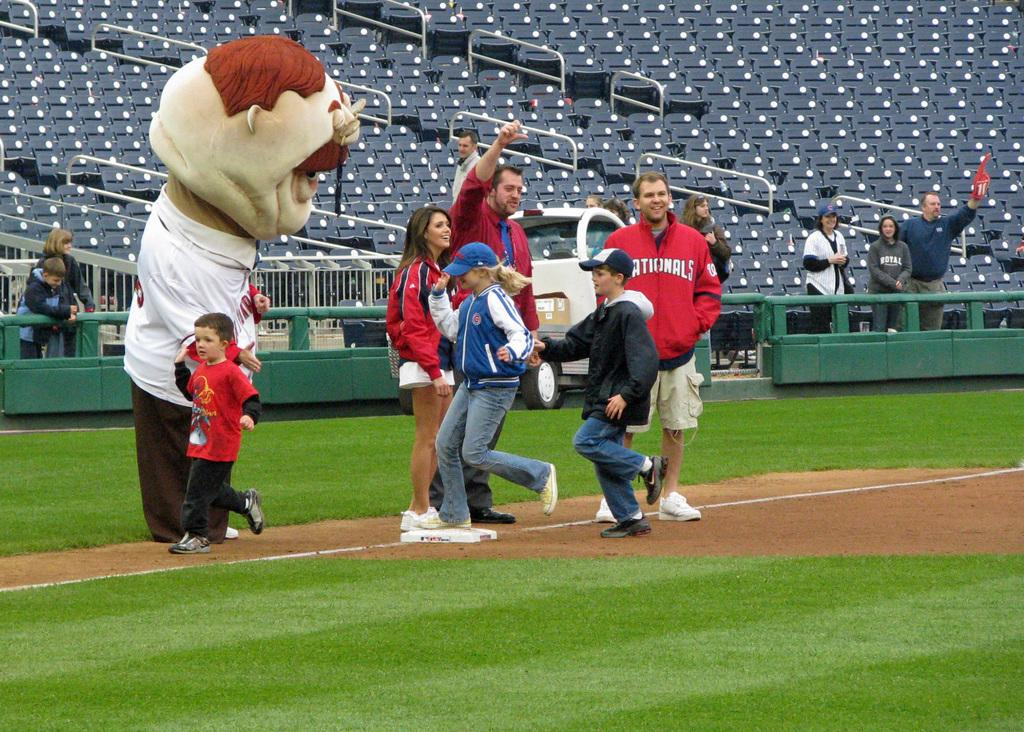<image>
Describe the image concisely. Nationals Jacket covers the upper body but not the legs. 